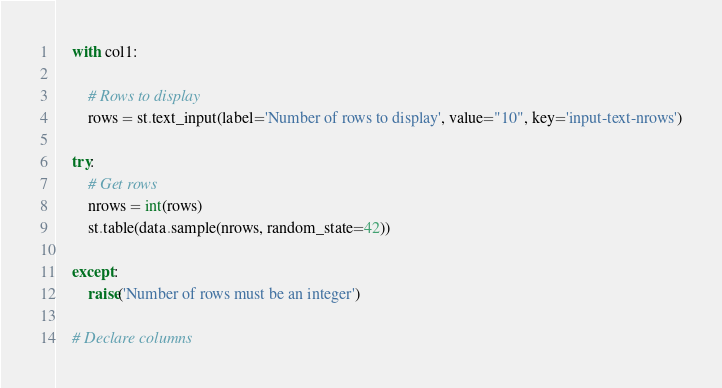<code> <loc_0><loc_0><loc_500><loc_500><_Python_>
    with col1:

        # Rows to display
        rows = st.text_input(label='Number of rows to display', value="10", key='input-text-nrows')

    try:
        # Get rows
        nrows = int(rows)
        st.table(data.sample(nrows, random_state=42))

    except:
        raise('Number of rows must be an integer')

    # Declare columns</code> 